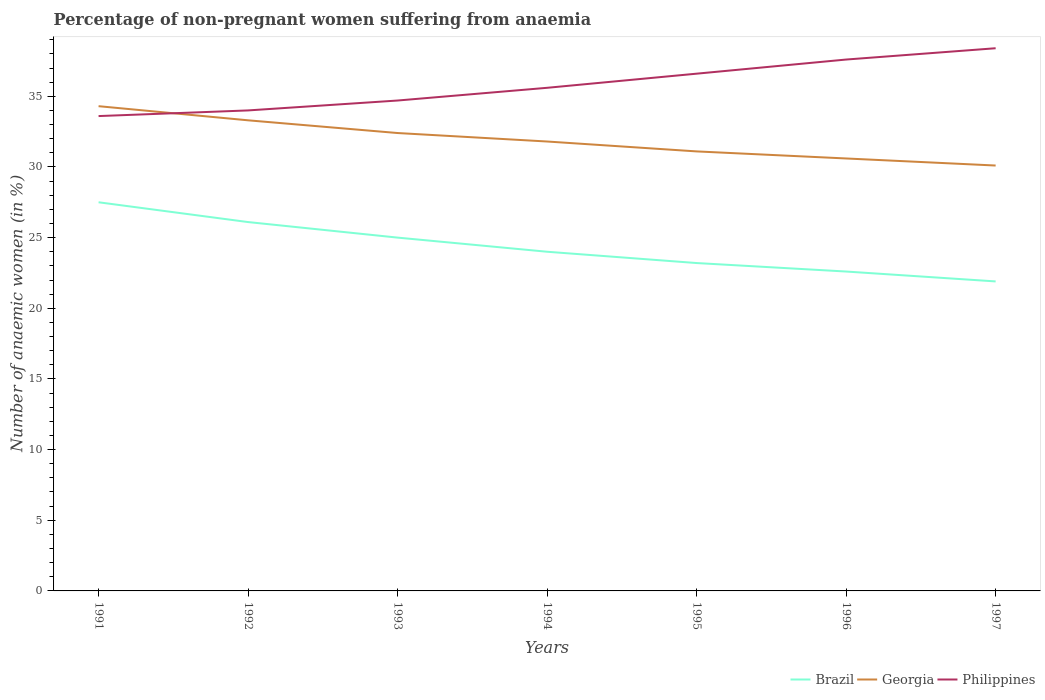Does the line corresponding to Brazil intersect with the line corresponding to Georgia?
Your response must be concise. No. Is the number of lines equal to the number of legend labels?
Your response must be concise. Yes. Across all years, what is the maximum percentage of non-pregnant women suffering from anaemia in Brazil?
Your response must be concise. 21.9. In which year was the percentage of non-pregnant women suffering from anaemia in Georgia maximum?
Make the answer very short. 1997. What is the difference between the highest and the second highest percentage of non-pregnant women suffering from anaemia in Georgia?
Give a very brief answer. 4.2. What is the difference between the highest and the lowest percentage of non-pregnant women suffering from anaemia in Georgia?
Offer a very short reply. 3. Is the percentage of non-pregnant women suffering from anaemia in Brazil strictly greater than the percentage of non-pregnant women suffering from anaemia in Philippines over the years?
Your answer should be compact. Yes. How many lines are there?
Keep it short and to the point. 3. Are the values on the major ticks of Y-axis written in scientific E-notation?
Provide a short and direct response. No. Does the graph contain grids?
Your answer should be very brief. No. Where does the legend appear in the graph?
Your response must be concise. Bottom right. What is the title of the graph?
Offer a very short reply. Percentage of non-pregnant women suffering from anaemia. What is the label or title of the Y-axis?
Provide a succinct answer. Number of anaemic women (in %). What is the Number of anaemic women (in %) of Georgia in 1991?
Provide a short and direct response. 34.3. What is the Number of anaemic women (in %) in Philippines in 1991?
Your answer should be compact. 33.6. What is the Number of anaemic women (in %) of Brazil in 1992?
Provide a succinct answer. 26.1. What is the Number of anaemic women (in %) of Georgia in 1992?
Provide a short and direct response. 33.3. What is the Number of anaemic women (in %) of Philippines in 1992?
Make the answer very short. 34. What is the Number of anaemic women (in %) of Brazil in 1993?
Provide a succinct answer. 25. What is the Number of anaemic women (in %) in Georgia in 1993?
Offer a terse response. 32.4. What is the Number of anaemic women (in %) in Philippines in 1993?
Offer a very short reply. 34.7. What is the Number of anaemic women (in %) in Georgia in 1994?
Offer a very short reply. 31.8. What is the Number of anaemic women (in %) in Philippines in 1994?
Provide a succinct answer. 35.6. What is the Number of anaemic women (in %) in Brazil in 1995?
Keep it short and to the point. 23.2. What is the Number of anaemic women (in %) of Georgia in 1995?
Make the answer very short. 31.1. What is the Number of anaemic women (in %) of Philippines in 1995?
Provide a short and direct response. 36.6. What is the Number of anaemic women (in %) in Brazil in 1996?
Your answer should be very brief. 22.6. What is the Number of anaemic women (in %) of Georgia in 1996?
Give a very brief answer. 30.6. What is the Number of anaemic women (in %) of Philippines in 1996?
Give a very brief answer. 37.6. What is the Number of anaemic women (in %) in Brazil in 1997?
Your answer should be compact. 21.9. What is the Number of anaemic women (in %) in Georgia in 1997?
Provide a succinct answer. 30.1. What is the Number of anaemic women (in %) in Philippines in 1997?
Make the answer very short. 38.4. Across all years, what is the maximum Number of anaemic women (in %) of Brazil?
Ensure brevity in your answer.  27.5. Across all years, what is the maximum Number of anaemic women (in %) of Georgia?
Give a very brief answer. 34.3. Across all years, what is the maximum Number of anaemic women (in %) of Philippines?
Ensure brevity in your answer.  38.4. Across all years, what is the minimum Number of anaemic women (in %) in Brazil?
Provide a short and direct response. 21.9. Across all years, what is the minimum Number of anaemic women (in %) in Georgia?
Your answer should be compact. 30.1. Across all years, what is the minimum Number of anaemic women (in %) of Philippines?
Make the answer very short. 33.6. What is the total Number of anaemic women (in %) of Brazil in the graph?
Your answer should be very brief. 170.3. What is the total Number of anaemic women (in %) in Georgia in the graph?
Your answer should be compact. 223.6. What is the total Number of anaemic women (in %) in Philippines in the graph?
Ensure brevity in your answer.  250.5. What is the difference between the Number of anaemic women (in %) of Philippines in 1991 and that in 1993?
Provide a succinct answer. -1.1. What is the difference between the Number of anaemic women (in %) in Philippines in 1991 and that in 1994?
Your answer should be very brief. -2. What is the difference between the Number of anaemic women (in %) of Brazil in 1991 and that in 1995?
Offer a very short reply. 4.3. What is the difference between the Number of anaemic women (in %) in Philippines in 1991 and that in 1995?
Your answer should be compact. -3. What is the difference between the Number of anaemic women (in %) in Georgia in 1991 and that in 1996?
Offer a terse response. 3.7. What is the difference between the Number of anaemic women (in %) in Brazil in 1992 and that in 1994?
Your response must be concise. 2.1. What is the difference between the Number of anaemic women (in %) in Georgia in 1992 and that in 1994?
Provide a short and direct response. 1.5. What is the difference between the Number of anaemic women (in %) in Philippines in 1992 and that in 1994?
Give a very brief answer. -1.6. What is the difference between the Number of anaemic women (in %) in Brazil in 1992 and that in 1995?
Provide a short and direct response. 2.9. What is the difference between the Number of anaemic women (in %) of Georgia in 1992 and that in 1995?
Your answer should be very brief. 2.2. What is the difference between the Number of anaemic women (in %) of Georgia in 1992 and that in 1996?
Make the answer very short. 2.7. What is the difference between the Number of anaemic women (in %) of Brazil in 1992 and that in 1997?
Make the answer very short. 4.2. What is the difference between the Number of anaemic women (in %) of Georgia in 1992 and that in 1997?
Keep it short and to the point. 3.2. What is the difference between the Number of anaemic women (in %) of Brazil in 1993 and that in 1994?
Provide a succinct answer. 1. What is the difference between the Number of anaemic women (in %) in Georgia in 1993 and that in 1994?
Provide a short and direct response. 0.6. What is the difference between the Number of anaemic women (in %) in Philippines in 1993 and that in 1994?
Give a very brief answer. -0.9. What is the difference between the Number of anaemic women (in %) of Philippines in 1993 and that in 1995?
Ensure brevity in your answer.  -1.9. What is the difference between the Number of anaemic women (in %) of Brazil in 1993 and that in 1996?
Your response must be concise. 2.4. What is the difference between the Number of anaemic women (in %) of Georgia in 1993 and that in 1996?
Your response must be concise. 1.8. What is the difference between the Number of anaemic women (in %) in Philippines in 1993 and that in 1996?
Keep it short and to the point. -2.9. What is the difference between the Number of anaemic women (in %) in Georgia in 1993 and that in 1997?
Give a very brief answer. 2.3. What is the difference between the Number of anaemic women (in %) of Philippines in 1993 and that in 1997?
Your answer should be very brief. -3.7. What is the difference between the Number of anaemic women (in %) in Brazil in 1994 and that in 1995?
Offer a terse response. 0.8. What is the difference between the Number of anaemic women (in %) in Georgia in 1994 and that in 1995?
Ensure brevity in your answer.  0.7. What is the difference between the Number of anaemic women (in %) of Philippines in 1994 and that in 1996?
Your answer should be very brief. -2. What is the difference between the Number of anaemic women (in %) of Philippines in 1994 and that in 1997?
Your answer should be very brief. -2.8. What is the difference between the Number of anaemic women (in %) of Brazil in 1995 and that in 1996?
Provide a succinct answer. 0.6. What is the difference between the Number of anaemic women (in %) in Georgia in 1995 and that in 1996?
Your response must be concise. 0.5. What is the difference between the Number of anaemic women (in %) of Philippines in 1995 and that in 1997?
Provide a succinct answer. -1.8. What is the difference between the Number of anaemic women (in %) in Georgia in 1996 and that in 1997?
Your response must be concise. 0.5. What is the difference between the Number of anaemic women (in %) in Georgia in 1991 and the Number of anaemic women (in %) in Philippines in 1992?
Make the answer very short. 0.3. What is the difference between the Number of anaemic women (in %) of Brazil in 1991 and the Number of anaemic women (in %) of Georgia in 1993?
Ensure brevity in your answer.  -4.9. What is the difference between the Number of anaemic women (in %) in Georgia in 1991 and the Number of anaemic women (in %) in Philippines in 1993?
Ensure brevity in your answer.  -0.4. What is the difference between the Number of anaemic women (in %) of Brazil in 1991 and the Number of anaemic women (in %) of Philippines in 1995?
Offer a very short reply. -9.1. What is the difference between the Number of anaemic women (in %) in Brazil in 1991 and the Number of anaemic women (in %) in Philippines in 1996?
Offer a terse response. -10.1. What is the difference between the Number of anaemic women (in %) in Brazil in 1991 and the Number of anaemic women (in %) in Georgia in 1997?
Make the answer very short. -2.6. What is the difference between the Number of anaemic women (in %) of Brazil in 1992 and the Number of anaemic women (in %) of Philippines in 1993?
Offer a terse response. -8.6. What is the difference between the Number of anaemic women (in %) of Brazil in 1992 and the Number of anaemic women (in %) of Philippines in 1994?
Give a very brief answer. -9.5. What is the difference between the Number of anaemic women (in %) of Georgia in 1992 and the Number of anaemic women (in %) of Philippines in 1994?
Your answer should be very brief. -2.3. What is the difference between the Number of anaemic women (in %) of Georgia in 1992 and the Number of anaemic women (in %) of Philippines in 1995?
Your answer should be compact. -3.3. What is the difference between the Number of anaemic women (in %) in Brazil in 1992 and the Number of anaemic women (in %) in Georgia in 1996?
Offer a very short reply. -4.5. What is the difference between the Number of anaemic women (in %) in Brazil in 1992 and the Number of anaemic women (in %) in Philippines in 1996?
Offer a very short reply. -11.5. What is the difference between the Number of anaemic women (in %) in Georgia in 1992 and the Number of anaemic women (in %) in Philippines in 1996?
Keep it short and to the point. -4.3. What is the difference between the Number of anaemic women (in %) in Brazil in 1992 and the Number of anaemic women (in %) in Georgia in 1997?
Offer a terse response. -4. What is the difference between the Number of anaemic women (in %) of Brazil in 1993 and the Number of anaemic women (in %) of Georgia in 1994?
Your response must be concise. -6.8. What is the difference between the Number of anaemic women (in %) of Brazil in 1993 and the Number of anaemic women (in %) of Philippines in 1994?
Make the answer very short. -10.6. What is the difference between the Number of anaemic women (in %) of Georgia in 1993 and the Number of anaemic women (in %) of Philippines in 1994?
Your answer should be very brief. -3.2. What is the difference between the Number of anaemic women (in %) in Brazil in 1993 and the Number of anaemic women (in %) in Philippines in 1995?
Your answer should be compact. -11.6. What is the difference between the Number of anaemic women (in %) of Georgia in 1993 and the Number of anaemic women (in %) of Philippines in 1995?
Provide a short and direct response. -4.2. What is the difference between the Number of anaemic women (in %) in Brazil in 1993 and the Number of anaemic women (in %) in Georgia in 1996?
Offer a terse response. -5.6. What is the difference between the Number of anaemic women (in %) of Georgia in 1993 and the Number of anaemic women (in %) of Philippines in 1996?
Ensure brevity in your answer.  -5.2. What is the difference between the Number of anaemic women (in %) in Georgia in 1993 and the Number of anaemic women (in %) in Philippines in 1997?
Give a very brief answer. -6. What is the difference between the Number of anaemic women (in %) of Brazil in 1994 and the Number of anaemic women (in %) of Georgia in 1995?
Offer a terse response. -7.1. What is the difference between the Number of anaemic women (in %) in Georgia in 1994 and the Number of anaemic women (in %) in Philippines in 1995?
Provide a succinct answer. -4.8. What is the difference between the Number of anaemic women (in %) in Brazil in 1994 and the Number of anaemic women (in %) in Georgia in 1996?
Make the answer very short. -6.6. What is the difference between the Number of anaemic women (in %) in Georgia in 1994 and the Number of anaemic women (in %) in Philippines in 1996?
Your answer should be very brief. -5.8. What is the difference between the Number of anaemic women (in %) of Brazil in 1994 and the Number of anaemic women (in %) of Philippines in 1997?
Provide a succinct answer. -14.4. What is the difference between the Number of anaemic women (in %) of Georgia in 1994 and the Number of anaemic women (in %) of Philippines in 1997?
Provide a short and direct response. -6.6. What is the difference between the Number of anaemic women (in %) of Brazil in 1995 and the Number of anaemic women (in %) of Philippines in 1996?
Your response must be concise. -14.4. What is the difference between the Number of anaemic women (in %) in Georgia in 1995 and the Number of anaemic women (in %) in Philippines in 1996?
Ensure brevity in your answer.  -6.5. What is the difference between the Number of anaemic women (in %) of Brazil in 1995 and the Number of anaemic women (in %) of Georgia in 1997?
Your answer should be compact. -6.9. What is the difference between the Number of anaemic women (in %) in Brazil in 1995 and the Number of anaemic women (in %) in Philippines in 1997?
Make the answer very short. -15.2. What is the difference between the Number of anaemic women (in %) of Georgia in 1995 and the Number of anaemic women (in %) of Philippines in 1997?
Your answer should be very brief. -7.3. What is the difference between the Number of anaemic women (in %) in Brazil in 1996 and the Number of anaemic women (in %) in Georgia in 1997?
Your response must be concise. -7.5. What is the difference between the Number of anaemic women (in %) of Brazil in 1996 and the Number of anaemic women (in %) of Philippines in 1997?
Your answer should be very brief. -15.8. What is the average Number of anaemic women (in %) in Brazil per year?
Give a very brief answer. 24.33. What is the average Number of anaemic women (in %) of Georgia per year?
Offer a terse response. 31.94. What is the average Number of anaemic women (in %) in Philippines per year?
Offer a terse response. 35.79. In the year 1991, what is the difference between the Number of anaemic women (in %) of Brazil and Number of anaemic women (in %) of Georgia?
Make the answer very short. -6.8. In the year 1991, what is the difference between the Number of anaemic women (in %) of Georgia and Number of anaemic women (in %) of Philippines?
Offer a terse response. 0.7. In the year 1992, what is the difference between the Number of anaemic women (in %) of Brazil and Number of anaemic women (in %) of Philippines?
Provide a short and direct response. -7.9. In the year 1992, what is the difference between the Number of anaemic women (in %) of Georgia and Number of anaemic women (in %) of Philippines?
Keep it short and to the point. -0.7. In the year 1993, what is the difference between the Number of anaemic women (in %) in Brazil and Number of anaemic women (in %) in Georgia?
Offer a terse response. -7.4. In the year 1993, what is the difference between the Number of anaemic women (in %) of Brazil and Number of anaemic women (in %) of Philippines?
Keep it short and to the point. -9.7. In the year 1994, what is the difference between the Number of anaemic women (in %) of Brazil and Number of anaemic women (in %) of Georgia?
Provide a short and direct response. -7.8. In the year 1994, what is the difference between the Number of anaemic women (in %) of Brazil and Number of anaemic women (in %) of Philippines?
Keep it short and to the point. -11.6. In the year 1994, what is the difference between the Number of anaemic women (in %) in Georgia and Number of anaemic women (in %) in Philippines?
Ensure brevity in your answer.  -3.8. In the year 1995, what is the difference between the Number of anaemic women (in %) of Brazil and Number of anaemic women (in %) of Georgia?
Keep it short and to the point. -7.9. In the year 1996, what is the difference between the Number of anaemic women (in %) in Brazil and Number of anaemic women (in %) in Philippines?
Give a very brief answer. -15. In the year 1997, what is the difference between the Number of anaemic women (in %) of Brazil and Number of anaemic women (in %) of Georgia?
Offer a terse response. -8.2. In the year 1997, what is the difference between the Number of anaemic women (in %) in Brazil and Number of anaemic women (in %) in Philippines?
Your response must be concise. -16.5. In the year 1997, what is the difference between the Number of anaemic women (in %) of Georgia and Number of anaemic women (in %) of Philippines?
Make the answer very short. -8.3. What is the ratio of the Number of anaemic women (in %) of Brazil in 1991 to that in 1992?
Make the answer very short. 1.05. What is the ratio of the Number of anaemic women (in %) of Georgia in 1991 to that in 1993?
Keep it short and to the point. 1.06. What is the ratio of the Number of anaemic women (in %) of Philippines in 1991 to that in 1993?
Your answer should be compact. 0.97. What is the ratio of the Number of anaemic women (in %) in Brazil in 1991 to that in 1994?
Ensure brevity in your answer.  1.15. What is the ratio of the Number of anaemic women (in %) in Georgia in 1991 to that in 1994?
Make the answer very short. 1.08. What is the ratio of the Number of anaemic women (in %) of Philippines in 1991 to that in 1994?
Keep it short and to the point. 0.94. What is the ratio of the Number of anaemic women (in %) in Brazil in 1991 to that in 1995?
Offer a very short reply. 1.19. What is the ratio of the Number of anaemic women (in %) in Georgia in 1991 to that in 1995?
Make the answer very short. 1.1. What is the ratio of the Number of anaemic women (in %) in Philippines in 1991 to that in 1995?
Your answer should be very brief. 0.92. What is the ratio of the Number of anaemic women (in %) in Brazil in 1991 to that in 1996?
Your answer should be compact. 1.22. What is the ratio of the Number of anaemic women (in %) of Georgia in 1991 to that in 1996?
Give a very brief answer. 1.12. What is the ratio of the Number of anaemic women (in %) in Philippines in 1991 to that in 1996?
Make the answer very short. 0.89. What is the ratio of the Number of anaemic women (in %) of Brazil in 1991 to that in 1997?
Offer a terse response. 1.26. What is the ratio of the Number of anaemic women (in %) in Georgia in 1991 to that in 1997?
Offer a very short reply. 1.14. What is the ratio of the Number of anaemic women (in %) of Philippines in 1991 to that in 1997?
Your answer should be very brief. 0.88. What is the ratio of the Number of anaemic women (in %) of Brazil in 1992 to that in 1993?
Your answer should be compact. 1.04. What is the ratio of the Number of anaemic women (in %) in Georgia in 1992 to that in 1993?
Provide a short and direct response. 1.03. What is the ratio of the Number of anaemic women (in %) in Philippines in 1992 to that in 1993?
Provide a succinct answer. 0.98. What is the ratio of the Number of anaemic women (in %) in Brazil in 1992 to that in 1994?
Keep it short and to the point. 1.09. What is the ratio of the Number of anaemic women (in %) in Georgia in 1992 to that in 1994?
Offer a very short reply. 1.05. What is the ratio of the Number of anaemic women (in %) in Philippines in 1992 to that in 1994?
Offer a very short reply. 0.96. What is the ratio of the Number of anaemic women (in %) of Brazil in 1992 to that in 1995?
Your answer should be compact. 1.12. What is the ratio of the Number of anaemic women (in %) in Georgia in 1992 to that in 1995?
Give a very brief answer. 1.07. What is the ratio of the Number of anaemic women (in %) of Philippines in 1992 to that in 1995?
Provide a succinct answer. 0.93. What is the ratio of the Number of anaemic women (in %) in Brazil in 1992 to that in 1996?
Offer a terse response. 1.15. What is the ratio of the Number of anaemic women (in %) of Georgia in 1992 to that in 1996?
Ensure brevity in your answer.  1.09. What is the ratio of the Number of anaemic women (in %) of Philippines in 1992 to that in 1996?
Your answer should be very brief. 0.9. What is the ratio of the Number of anaemic women (in %) in Brazil in 1992 to that in 1997?
Your answer should be very brief. 1.19. What is the ratio of the Number of anaemic women (in %) of Georgia in 1992 to that in 1997?
Provide a short and direct response. 1.11. What is the ratio of the Number of anaemic women (in %) of Philippines in 1992 to that in 1997?
Make the answer very short. 0.89. What is the ratio of the Number of anaemic women (in %) in Brazil in 1993 to that in 1994?
Make the answer very short. 1.04. What is the ratio of the Number of anaemic women (in %) in Georgia in 1993 to that in 1994?
Provide a succinct answer. 1.02. What is the ratio of the Number of anaemic women (in %) of Philippines in 1993 to that in 1994?
Give a very brief answer. 0.97. What is the ratio of the Number of anaemic women (in %) of Brazil in 1993 to that in 1995?
Keep it short and to the point. 1.08. What is the ratio of the Number of anaemic women (in %) of Georgia in 1993 to that in 1995?
Your response must be concise. 1.04. What is the ratio of the Number of anaemic women (in %) in Philippines in 1993 to that in 1995?
Provide a short and direct response. 0.95. What is the ratio of the Number of anaemic women (in %) in Brazil in 1993 to that in 1996?
Make the answer very short. 1.11. What is the ratio of the Number of anaemic women (in %) in Georgia in 1993 to that in 1996?
Provide a succinct answer. 1.06. What is the ratio of the Number of anaemic women (in %) in Philippines in 1993 to that in 1996?
Provide a short and direct response. 0.92. What is the ratio of the Number of anaemic women (in %) of Brazil in 1993 to that in 1997?
Make the answer very short. 1.14. What is the ratio of the Number of anaemic women (in %) in Georgia in 1993 to that in 1997?
Provide a short and direct response. 1.08. What is the ratio of the Number of anaemic women (in %) of Philippines in 1993 to that in 1997?
Make the answer very short. 0.9. What is the ratio of the Number of anaemic women (in %) in Brazil in 1994 to that in 1995?
Offer a terse response. 1.03. What is the ratio of the Number of anaemic women (in %) in Georgia in 1994 to that in 1995?
Ensure brevity in your answer.  1.02. What is the ratio of the Number of anaemic women (in %) in Philippines in 1994 to that in 1995?
Offer a very short reply. 0.97. What is the ratio of the Number of anaemic women (in %) in Brazil in 1994 to that in 1996?
Provide a short and direct response. 1.06. What is the ratio of the Number of anaemic women (in %) of Georgia in 1994 to that in 1996?
Give a very brief answer. 1.04. What is the ratio of the Number of anaemic women (in %) in Philippines in 1994 to that in 1996?
Ensure brevity in your answer.  0.95. What is the ratio of the Number of anaemic women (in %) in Brazil in 1994 to that in 1997?
Provide a short and direct response. 1.1. What is the ratio of the Number of anaemic women (in %) in Georgia in 1994 to that in 1997?
Your response must be concise. 1.06. What is the ratio of the Number of anaemic women (in %) of Philippines in 1994 to that in 1997?
Provide a succinct answer. 0.93. What is the ratio of the Number of anaemic women (in %) of Brazil in 1995 to that in 1996?
Provide a succinct answer. 1.03. What is the ratio of the Number of anaemic women (in %) in Georgia in 1995 to that in 1996?
Give a very brief answer. 1.02. What is the ratio of the Number of anaemic women (in %) of Philippines in 1995 to that in 1996?
Your answer should be very brief. 0.97. What is the ratio of the Number of anaemic women (in %) of Brazil in 1995 to that in 1997?
Your response must be concise. 1.06. What is the ratio of the Number of anaemic women (in %) of Georgia in 1995 to that in 1997?
Give a very brief answer. 1.03. What is the ratio of the Number of anaemic women (in %) in Philippines in 1995 to that in 1997?
Give a very brief answer. 0.95. What is the ratio of the Number of anaemic women (in %) in Brazil in 1996 to that in 1997?
Your answer should be compact. 1.03. What is the ratio of the Number of anaemic women (in %) in Georgia in 1996 to that in 1997?
Your answer should be compact. 1.02. What is the ratio of the Number of anaemic women (in %) in Philippines in 1996 to that in 1997?
Ensure brevity in your answer.  0.98. What is the difference between the highest and the second highest Number of anaemic women (in %) in Philippines?
Make the answer very short. 0.8. What is the difference between the highest and the lowest Number of anaemic women (in %) of Brazil?
Keep it short and to the point. 5.6. What is the difference between the highest and the lowest Number of anaemic women (in %) of Georgia?
Keep it short and to the point. 4.2. 